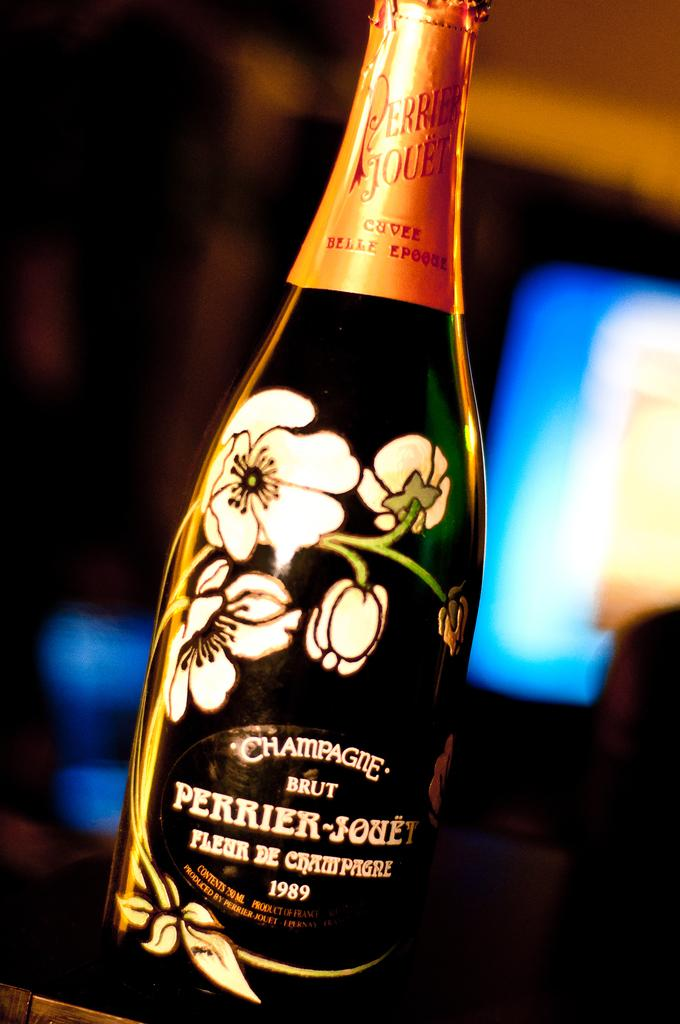<image>
Write a terse but informative summary of the picture. Beautiful flowers are on this green bottle of Perrier-Jouey. 